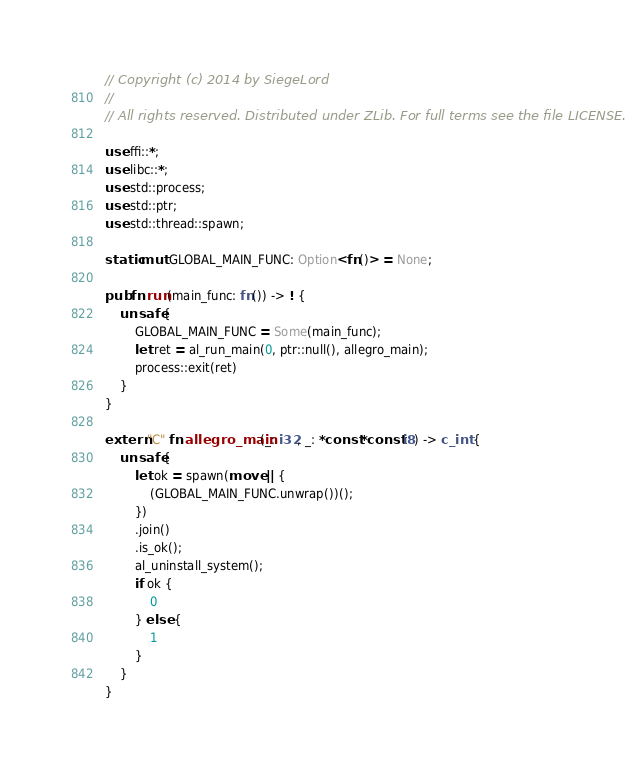Convert code to text. <code><loc_0><loc_0><loc_500><loc_500><_Rust_>// Copyright (c) 2014 by SiegeLord
//
// All rights reserved. Distributed under ZLib. For full terms see the file LICENSE.

use ffi::*;
use libc::*;
use std::process;
use std::ptr;
use std::thread::spawn;

static mut GLOBAL_MAIN_FUNC: Option<fn()> = None;

pub fn run(main_func: fn()) -> ! {
	unsafe {
		GLOBAL_MAIN_FUNC = Some(main_func);
		let ret = al_run_main(0, ptr::null(), allegro_main);
		process::exit(ret)
	}
}

extern "C" fn allegro_main(_: i32, _: *const *const i8) -> c_int {
	unsafe {
		let ok = spawn(move || {
			(GLOBAL_MAIN_FUNC.unwrap())();
		})
		.join()
		.is_ok();
		al_uninstall_system();
		if ok {
			0
		} else {
			1
		}
	}
}
</code> 